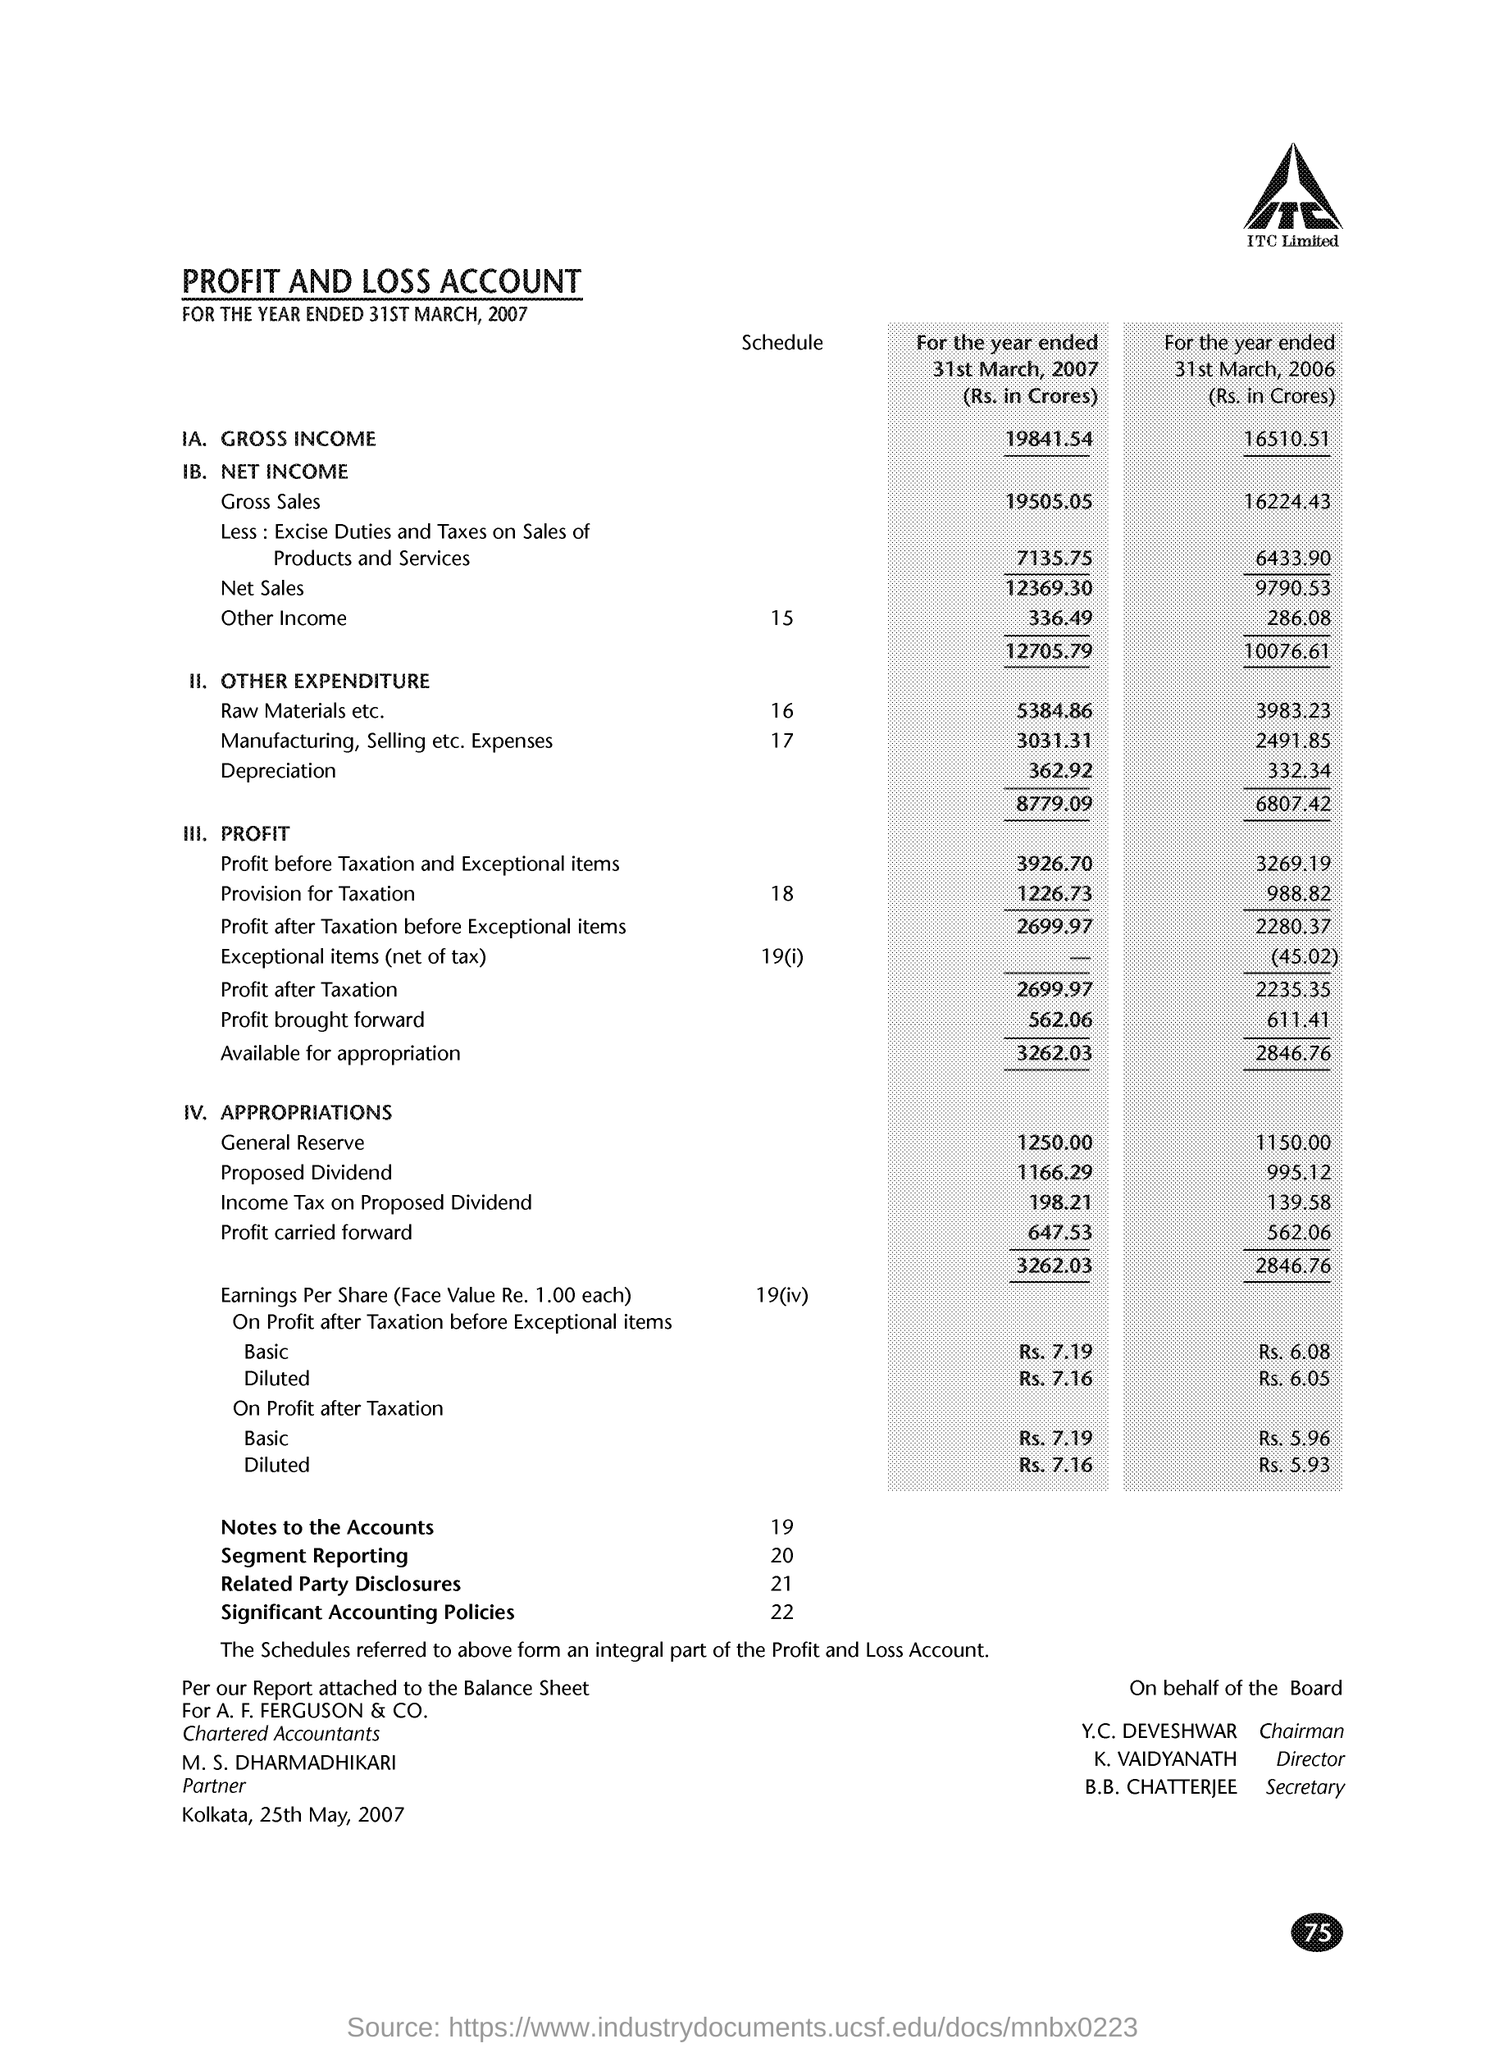For which date is the PROFIT AND LOSS ACCOUNT given?
Ensure brevity in your answer.  31ST MARCH, 2007. What is the Profit after Taxation for the year ended 31st March, 2007 (Rs. in Crores)?
Offer a very short reply. 2699.97. 